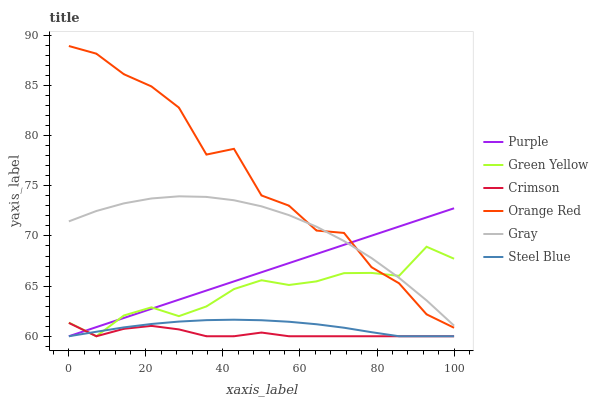Does Crimson have the minimum area under the curve?
Answer yes or no. Yes. Does Orange Red have the maximum area under the curve?
Answer yes or no. Yes. Does Purple have the minimum area under the curve?
Answer yes or no. No. Does Purple have the maximum area under the curve?
Answer yes or no. No. Is Purple the smoothest?
Answer yes or no. Yes. Is Orange Red the roughest?
Answer yes or no. Yes. Is Steel Blue the smoothest?
Answer yes or no. No. Is Steel Blue the roughest?
Answer yes or no. No. Does Purple have the lowest value?
Answer yes or no. Yes. Does Orange Red have the lowest value?
Answer yes or no. No. Does Orange Red have the highest value?
Answer yes or no. Yes. Does Purple have the highest value?
Answer yes or no. No. Is Steel Blue less than Orange Red?
Answer yes or no. Yes. Is Gray greater than Crimson?
Answer yes or no. Yes. Does Green Yellow intersect Steel Blue?
Answer yes or no. Yes. Is Green Yellow less than Steel Blue?
Answer yes or no. No. Is Green Yellow greater than Steel Blue?
Answer yes or no. No. Does Steel Blue intersect Orange Red?
Answer yes or no. No. 